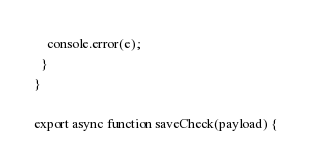Convert code to text. <code><loc_0><loc_0><loc_500><loc_500><_JavaScript_>    console.error(e);
  }
}

export async function saveCheck(payload) {</code> 